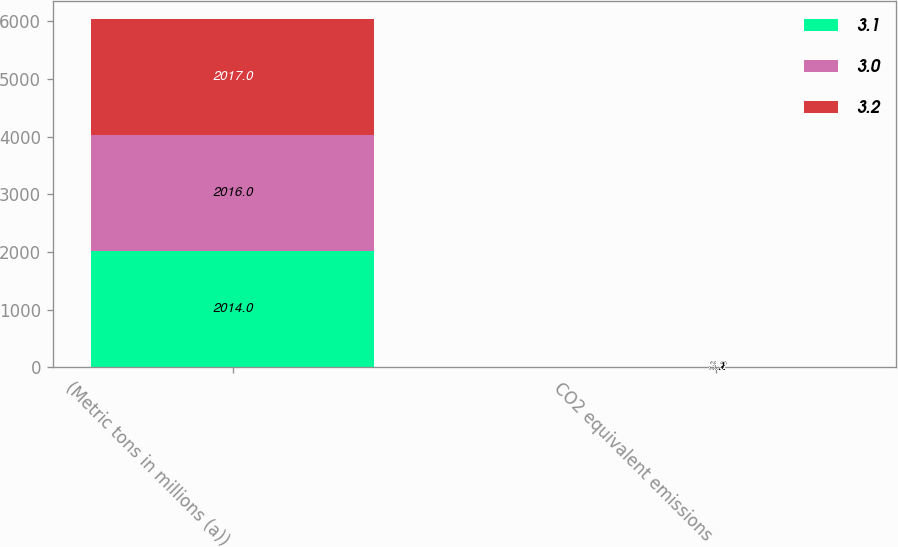Convert chart to OTSL. <chart><loc_0><loc_0><loc_500><loc_500><stacked_bar_chart><ecel><fcel>(Metric tons in millions (a))<fcel>CO2 equivalent emissions<nl><fcel>3.1<fcel>2014<fcel>3.2<nl><fcel>3<fcel>2016<fcel>3.1<nl><fcel>3.2<fcel>2017<fcel>3<nl></chart> 